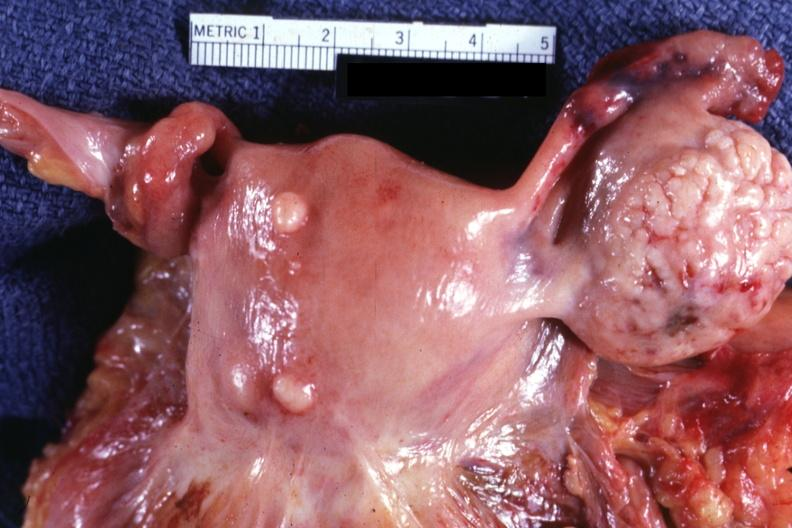where does this part belong to?
Answer the question using a single word or phrase. Female reproductive system 